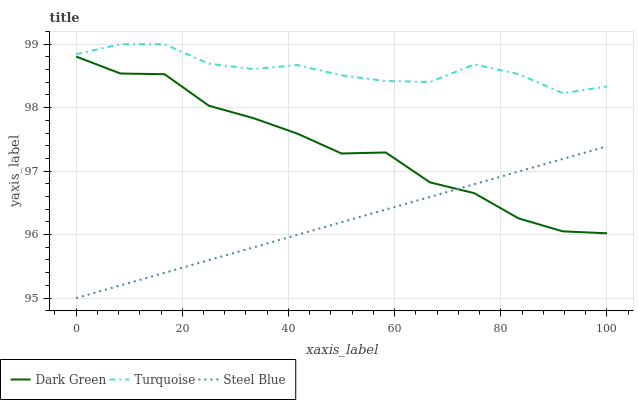Does Steel Blue have the minimum area under the curve?
Answer yes or no. Yes. Does Turquoise have the maximum area under the curve?
Answer yes or no. Yes. Does Dark Green have the minimum area under the curve?
Answer yes or no. No. Does Dark Green have the maximum area under the curve?
Answer yes or no. No. Is Steel Blue the smoothest?
Answer yes or no. Yes. Is Dark Green the roughest?
Answer yes or no. Yes. Is Dark Green the smoothest?
Answer yes or no. No. Is Steel Blue the roughest?
Answer yes or no. No. Does Dark Green have the lowest value?
Answer yes or no. No. Does Dark Green have the highest value?
Answer yes or no. No. Is Dark Green less than Turquoise?
Answer yes or no. Yes. Is Turquoise greater than Dark Green?
Answer yes or no. Yes. Does Dark Green intersect Turquoise?
Answer yes or no. No. 